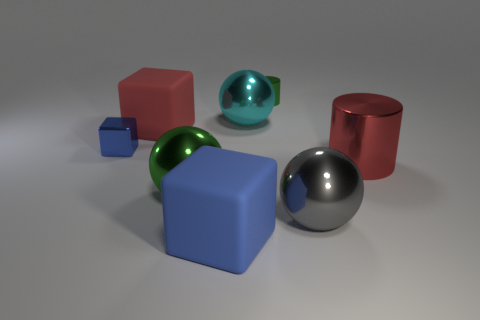Add 2 tiny blue balls. How many objects exist? 10 Subtract all balls. How many objects are left? 5 Add 3 yellow rubber things. How many yellow rubber things exist? 3 Subtract 0 blue spheres. How many objects are left? 8 Subtract all tiny green matte balls. Subtract all big cylinders. How many objects are left? 7 Add 3 blue objects. How many blue objects are left? 5 